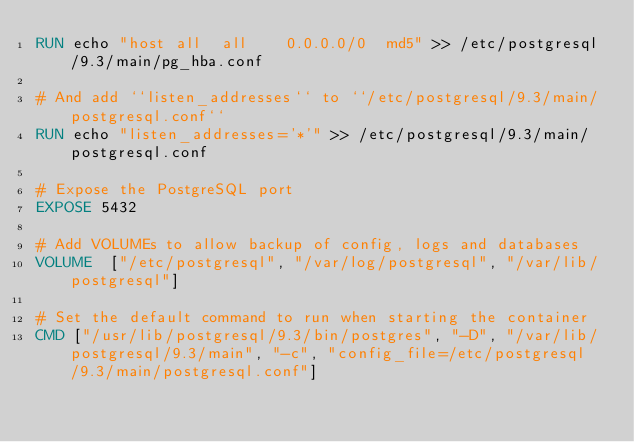Convert code to text. <code><loc_0><loc_0><loc_500><loc_500><_Dockerfile_>RUN echo "host all  all    0.0.0.0/0  md5" >> /etc/postgresql/9.3/main/pg_hba.conf

# And add ``listen_addresses`` to ``/etc/postgresql/9.3/main/postgresql.conf``
RUN echo "listen_addresses='*'" >> /etc/postgresql/9.3/main/postgresql.conf

# Expose the PostgreSQL port
EXPOSE 5432

# Add VOLUMEs to allow backup of config, logs and databases
VOLUME  ["/etc/postgresql", "/var/log/postgresql", "/var/lib/postgresql"]

# Set the default command to run when starting the container
CMD ["/usr/lib/postgresql/9.3/bin/postgres", "-D", "/var/lib/postgresql/9.3/main", "-c", "config_file=/etc/postgresql/9.3/main/postgresql.conf"]</code> 